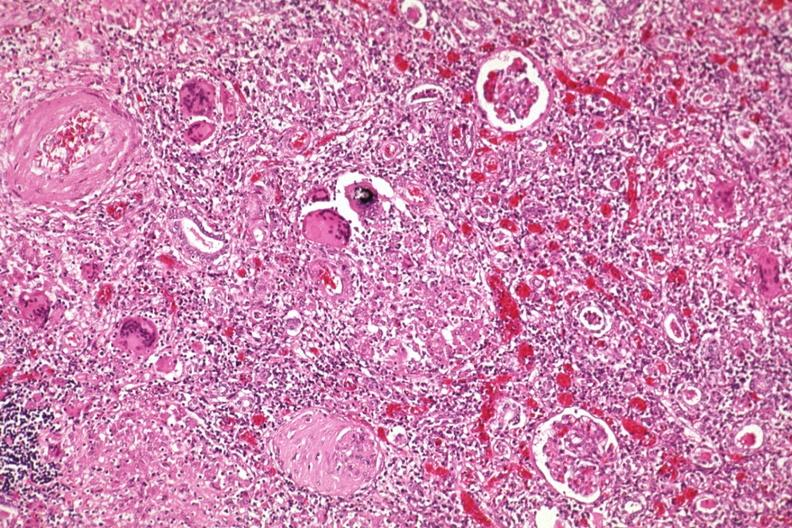what is present?
Answer the question using a single word or phrase. Sarcoidosis 